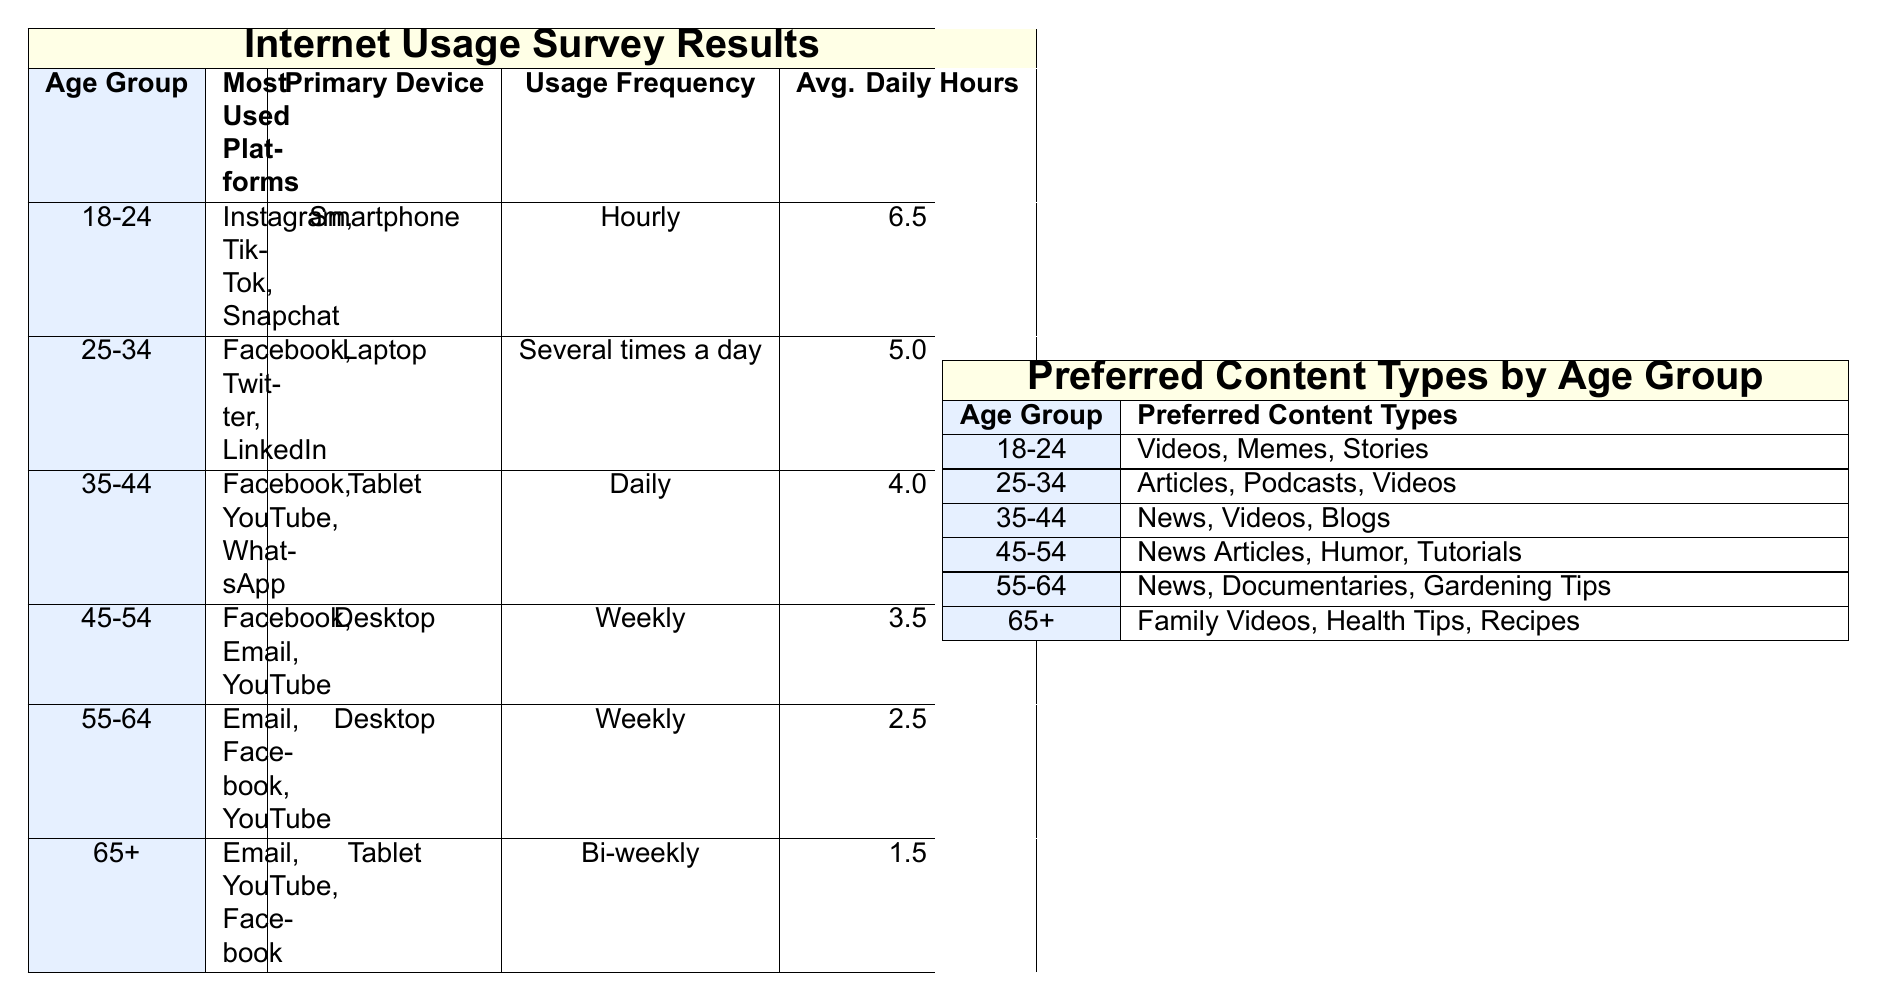What is the average daily internet usage in hours for the age group 25-34? According to the table, the average daily internet usage for the age group 25-34 is directly stated as 5.0 hours.
Answer: 5.0 hours Which age group prefers content types like articles and podcasts? The table indicates that the age group 25-34 prefers content types including articles and podcasts.
Answer: 25-34 Is the primary device for the age group 65 and over a smartphone? The table shows that the primary device for the age group 65 and over is a tablet, not a smartphone.
Answer: No What is the total average daily usage hours for all age groups combined? The average daily usage hours for the age groups are 6.5, 5.0, 4.0, 3.5, 2.5, and 1.5. Summing these gives 6.5 + 5.0 + 4.0 + 3.5 + 2.5 + 1.5 = 23.0 hours. Dividing by the 6 groups, the average is 23.0 / 6 = 3.8333.
Answer: 3.83 hours If someone uses the internet daily, which age group are they likely to belong to? The table indicates that the age group 35-44 uses the internet daily, while other age groups have different frequencies of usage.
Answer: 35-44 Which age group shows the highest average daily internet usage? By looking at the average daily usage hours in the table, the age group 18-24 has the highest average of 6.5 hours.
Answer: 18-24 In which age group is YouTube listed as a most used platform? The age groups that list YouTube as a most used platform are 35-44, 45-54, and 55-64.
Answer: 35-44, 45-54, 55-64 Comparing the average daily usage hours, how many hours less does the 55-64 age group use compared to the 25-34 age group? From the table, the 25-34 age group has an average usage of 5.0 hours, while the 55-64 age group has 2.5 hours. The difference is 5.0 - 2.5 = 2.5 hours less.
Answer: 2.5 hours What device is most commonly used by the age group 45-54? The table specifies that the primary device used by the age group 45-54 is a desktop.
Answer: Desktop Which preferred content type is unique to the 65 and over age group? The preferred content types for the 65 and over age group include family videos, health tips, and recipes, which are not listed for other age groups, making them unique to this group.
Answer: Family videos, health tips, recipes Is Facebook the most used platform across all age groups? The table shows that while Facebook is one of the most used platforms for several groups, it is not listed as the only or top platform for all age groups, particularly not for ages 18-24.
Answer: No 